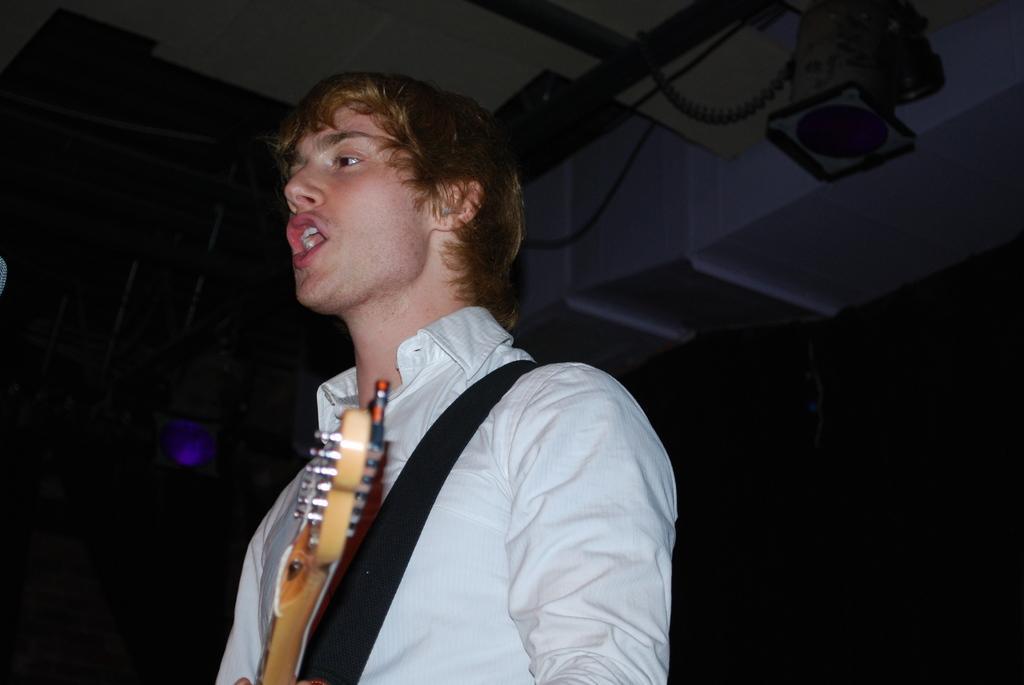Could you give a brief overview of what you see in this image? in this image i can see a man singing ,holding a guitar. he is wearing a shirt. 